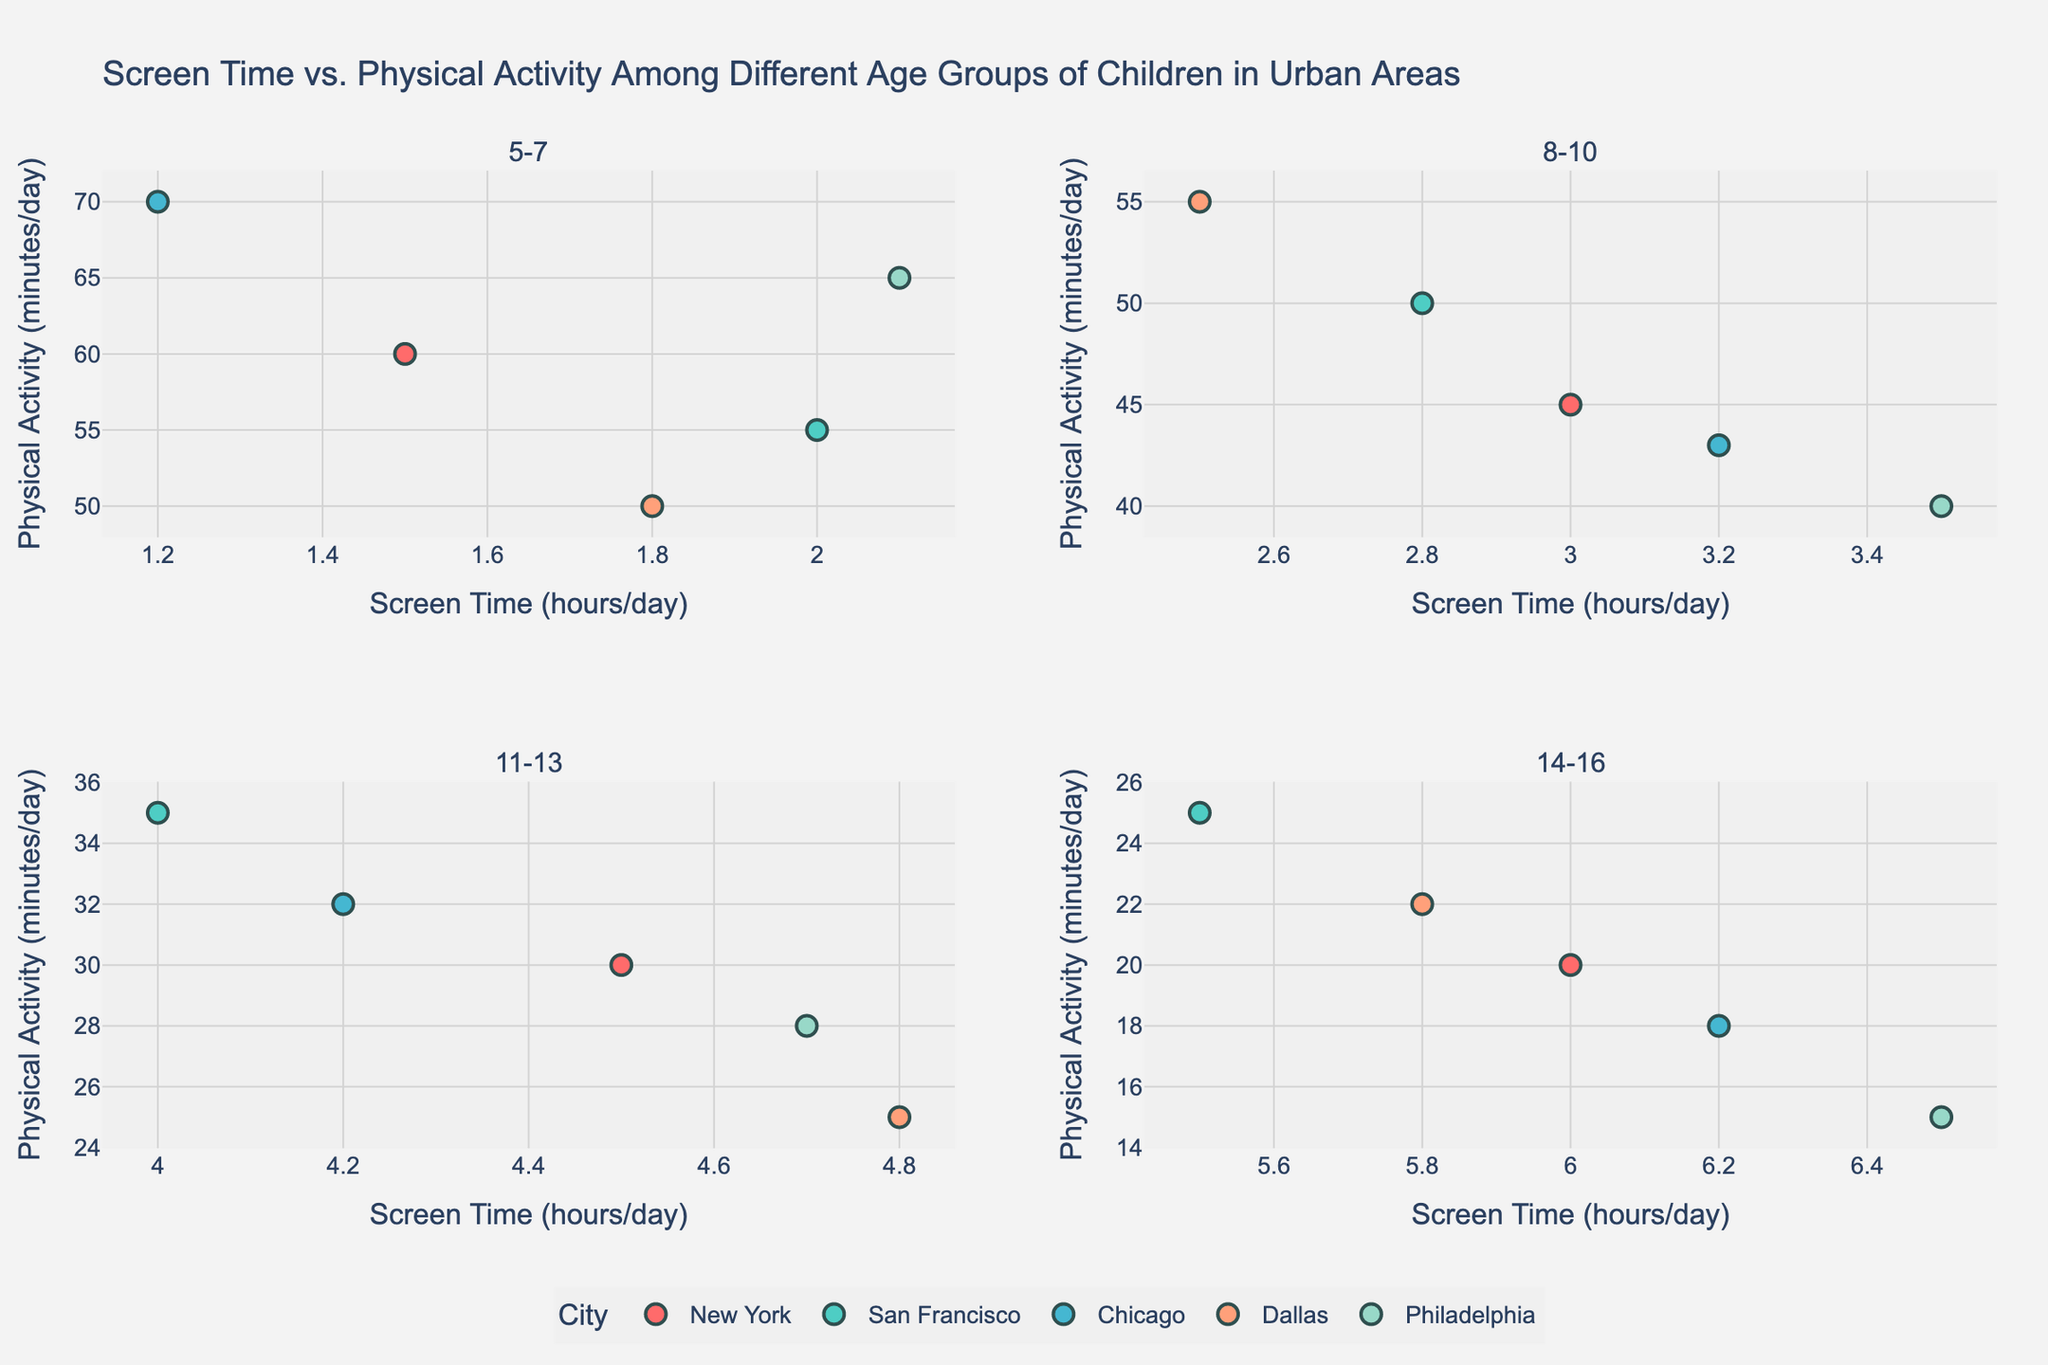What is the title of the figure? The title of the figure is shown at the top of the subplot.
Answer: Screen Time vs. Physical Activity Among Different Age Groups of Children in Urban Areas How many subplots are there in the figure? By observing the structure, we can count four subplots in the figure.
Answer: Four Which city has the highest screen time in the 8-10 age group? Look at the subplot for the 8-10 age group and identify the point with the highest screen time on the x-axis. The point representing Philadelphia has the highest screen time of 3.5 hours/day.
Answer: Philadelphia What is the range of physical activity for the 5-7 age group? In the subplot for the 5-7 age group, find the minimum and maximum values on the y-axis, which range from 50 to 70 minutes/day.
Answer: 50 to 70 minutes/day Is there a trend between screen time and physical activity as children grow older? Compare the subplots from younger age groups to older ones. The data shows increasing screen time and decreasing physical activity with age.
Answer: Yes, screen time increases and physical activity decreases What is the average screen time for children aged 11-13 in Dallas? Look at the subplot for the 11-13 age group and the points for Dallas. The screen times are 4.8 hours.
Answer: 4.8 hours/day Which age group has the widest range of physical activity? Compare the y-axis ranges of the subsets. The 5-7 age group has the widest range, from 50 to 70 minutes/day.
Answer: 5-7 age group Do any cities have a screen time of less than 2 hours/day for the 14-16 age group? Check the subplot for the 14-16 age group to see if any points are below 2 hours/day on the x-axis. There are none.
Answer: No What inference can be made regarding the relationship between screen time and physical activity across cities? In each subplot, most cities with higher screen time tend to have lower physical activity, indicating a negative correlation.
Answer: Higher screen time generally means lower physical activity 